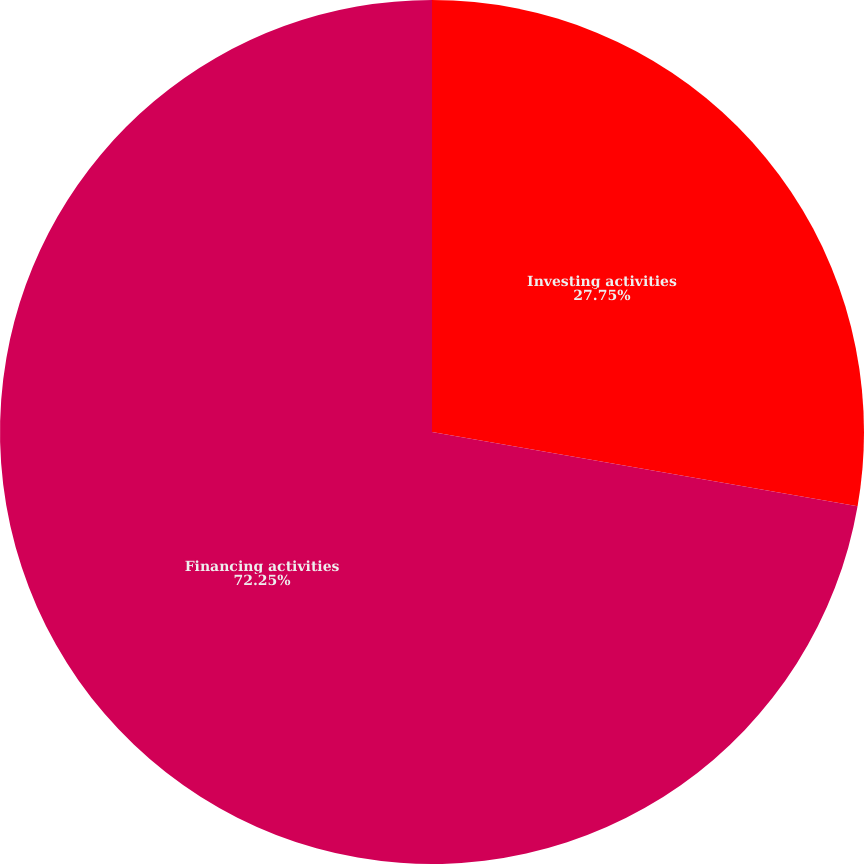Convert chart. <chart><loc_0><loc_0><loc_500><loc_500><pie_chart><fcel>Investing activities<fcel>Financing activities<nl><fcel>27.75%<fcel>72.25%<nl></chart> 